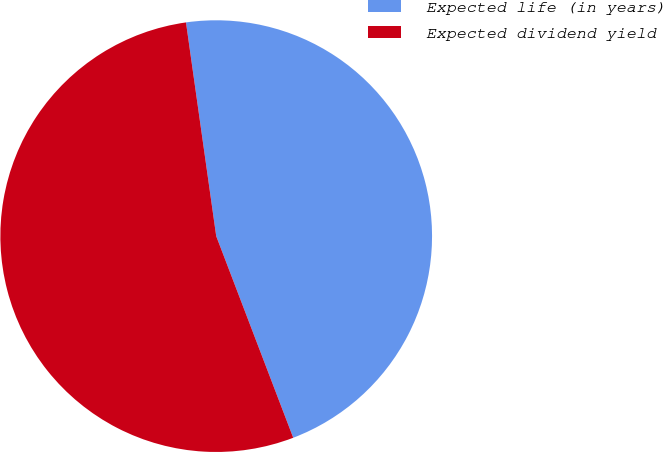<chart> <loc_0><loc_0><loc_500><loc_500><pie_chart><fcel>Expected life (in years)<fcel>Expected dividend yield<nl><fcel>46.43%<fcel>53.57%<nl></chart> 